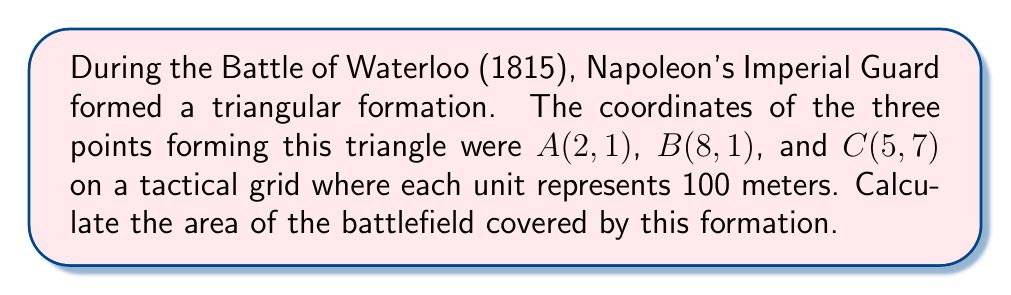Help me with this question. To solve this problem, we'll use the formula for the area of a triangle given the coordinates of its vertices. The formula is:

$$\text{Area} = \frac{1}{2}|x_1(y_2 - y_3) + x_2(y_3 - y_1) + x_3(y_1 - y_2)|$$

Where $(x_1, y_1)$, $(x_2, y_2)$, and $(x_3, y_3)$ are the coordinates of the three vertices.

Step 1: Identify the coordinates
A(2, 1), B(8, 1), C(5, 7)

Step 2: Plug the coordinates into the formula
$$\text{Area} = \frac{1}{2}|2(1 - 7) + 8(7 - 1) + 5(1 - 1)|$$

Step 3: Simplify the expressions inside the parentheses
$$\text{Area} = \frac{1}{2}|2(-6) + 8(6) + 5(0)|$$

Step 4: Multiply
$$\text{Area} = \frac{1}{2}|-12 + 48 + 0|$$

Step 5: Add the terms inside the absolute value signs
$$\text{Area} = \frac{1}{2}|36|$$

Step 6: Evaluate the absolute value
$$\text{Area} = \frac{1}{2}(36)$$

Step 7: Multiply
$$\text{Area} = 18$$

Since each unit represents 100 meters, the actual area is:
$$18 \times 100^2 = 180,000 \text{ square meters}$$

[asy]
unitsize(10mm);
draw((0,0)--(10,0)--(0,10)--cycle);
dot((2,1));
dot((8,1));
dot((5,7));
label("A(2,1)", (2,1), SW);
label("B(8,1)", (8,1), SE);
label("C(5,7)", (5,7), N);
label("Imperial Guard Formation", (5,3), S);
[/asy]
Answer: 180,000 square meters 